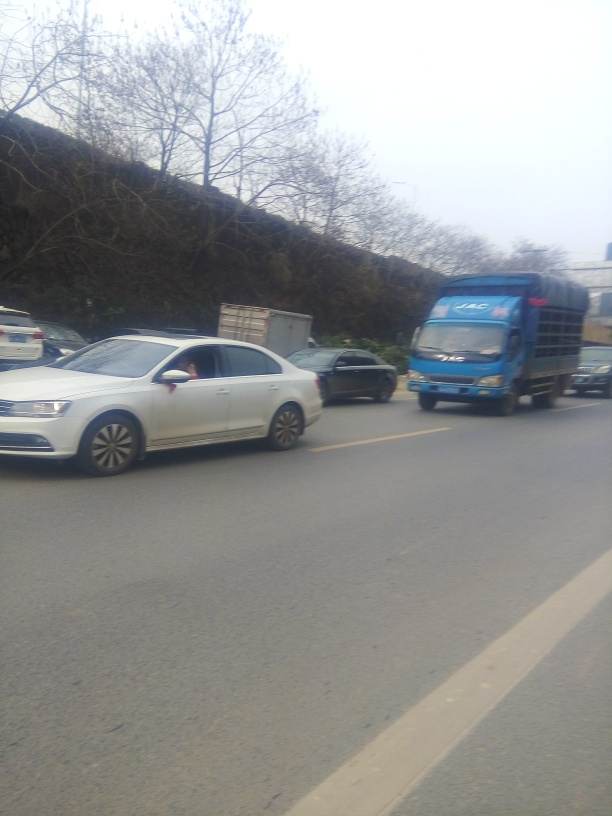Can you describe the vehicles in the image? Certainly, the image features a mix of vehicles on a road, including a white sedan at the forefront and a blue heavy-duty truck visible in the opposite lane. The vehicles indicate a busy traffic scene, possibly on a city road or highway. Does it look like there might be traffic issues in the area? Based on the vehicle spacing and position, there doesn't appear to be a traffic jam, but the presence of multiple vehicles in motion suggests it's a high-traffic area. There could be potential for delays, especially if this is a snapshot of a typically congested road. 